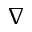<formula> <loc_0><loc_0><loc_500><loc_500>\nabla</formula> 